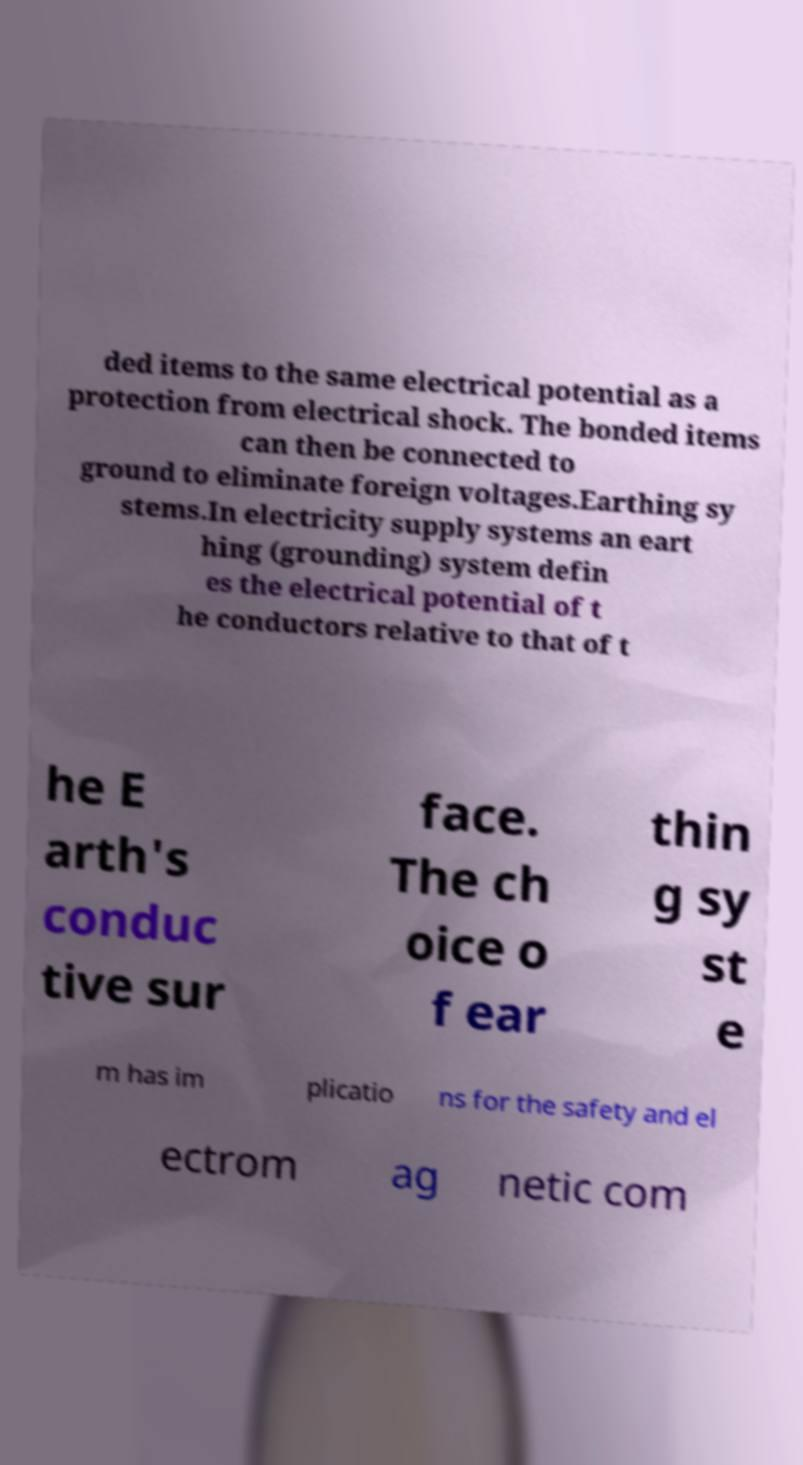Please identify and transcribe the text found in this image. ded items to the same electrical potential as a protection from electrical shock. The bonded items can then be connected to ground to eliminate foreign voltages.Earthing sy stems.In electricity supply systems an eart hing (grounding) system defin es the electrical potential of t he conductors relative to that of t he E arth's conduc tive sur face. The ch oice o f ear thin g sy st e m has im plicatio ns for the safety and el ectrom ag netic com 